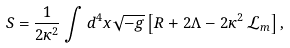Convert formula to latex. <formula><loc_0><loc_0><loc_500><loc_500>S = \frac { 1 } { 2 \kappa ^ { 2 } } \int { d ^ { 4 } x \sqrt { - g } \left [ R + 2 \Lambda - 2 \kappa ^ { 2 } \, { \mathcal { L } } _ { m } \right ] } \, ,</formula> 